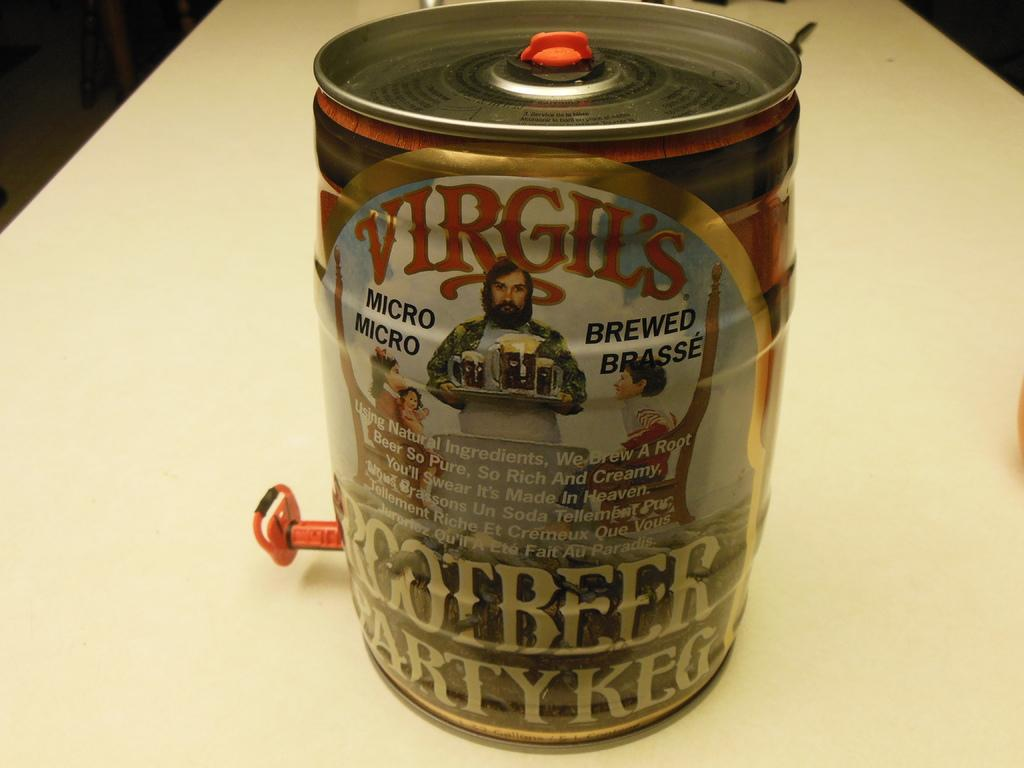<image>
Write a terse but informative summary of the picture. A mini keg of Virgil's Root Beer on a table. 